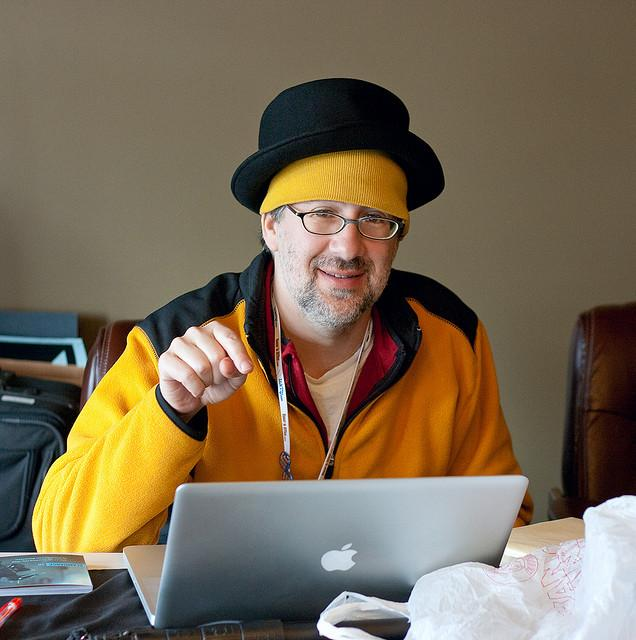What is the man's hat called?

Choices:
A) felt
B) bowler hat
C) coach
D) trilby bowler hat 